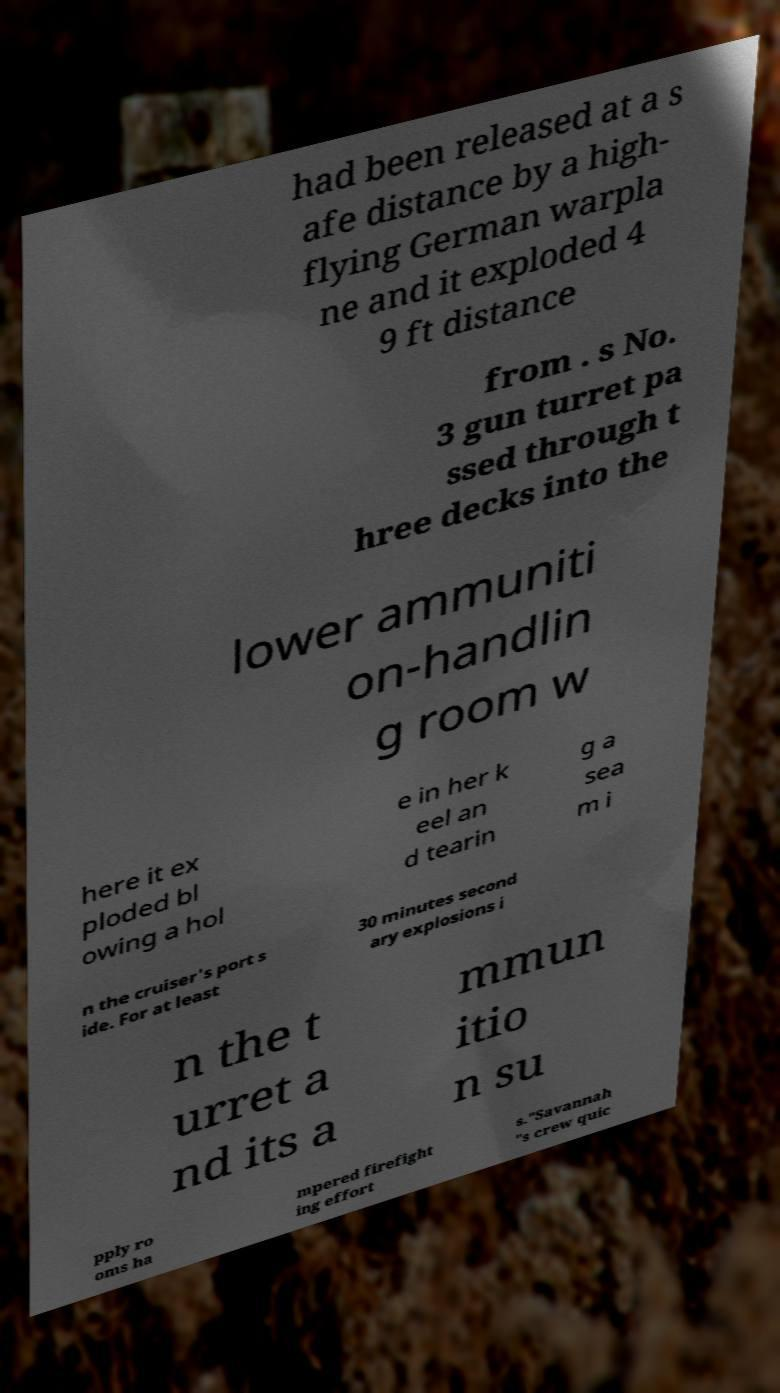Could you assist in decoding the text presented in this image and type it out clearly? had been released at a s afe distance by a high- flying German warpla ne and it exploded 4 9 ft distance from . s No. 3 gun turret pa ssed through t hree decks into the lower ammuniti on-handlin g room w here it ex ploded bl owing a hol e in her k eel an d tearin g a sea m i n the cruiser's port s ide. For at least 30 minutes second ary explosions i n the t urret a nd its a mmun itio n su pply ro oms ha mpered firefight ing effort s."Savannah "s crew quic 